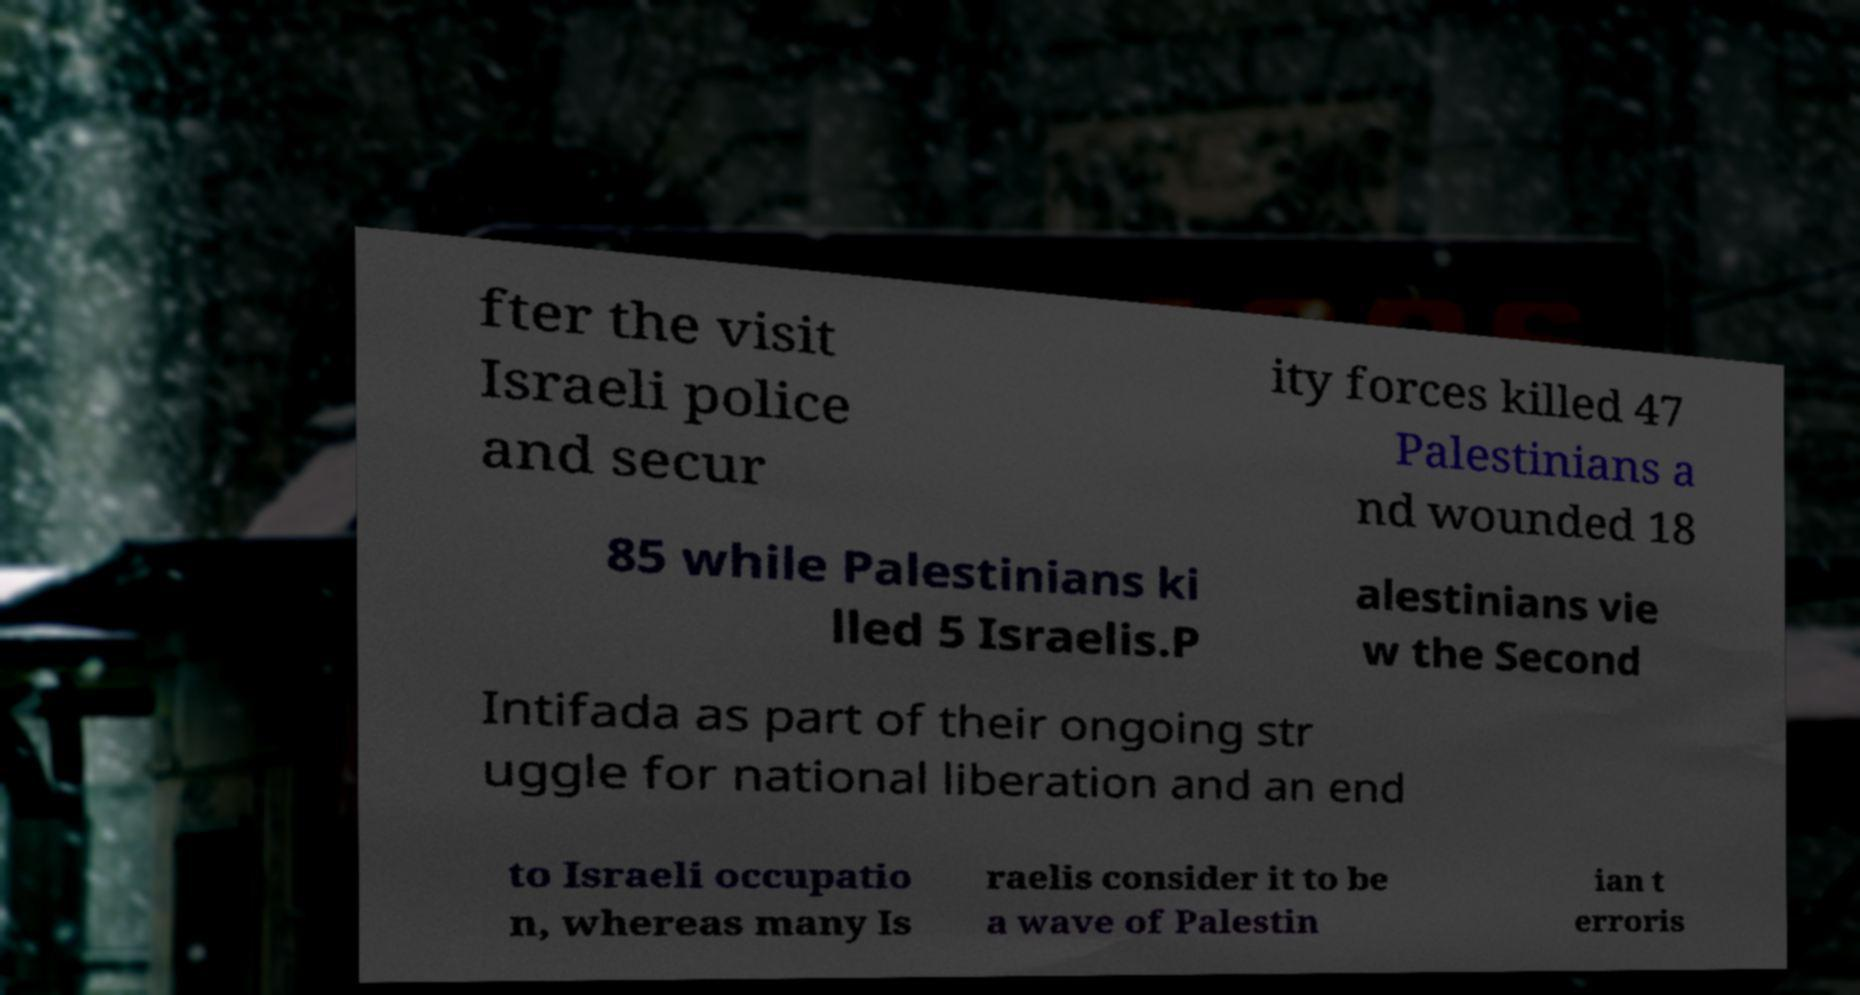For documentation purposes, I need the text within this image transcribed. Could you provide that? fter the visit Israeli police and secur ity forces killed 47 Palestinians a nd wounded 18 85 while Palestinians ki lled 5 Israelis.P alestinians vie w the Second Intifada as part of their ongoing str uggle for national liberation and an end to Israeli occupatio n, whereas many Is raelis consider it to be a wave of Palestin ian t erroris 